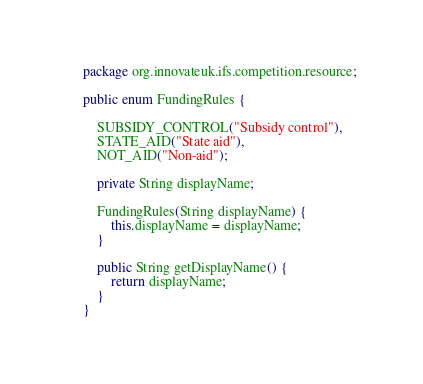Convert code to text. <code><loc_0><loc_0><loc_500><loc_500><_Java_>package org.innovateuk.ifs.competition.resource;

public enum FundingRules {

    SUBSIDY_CONTROL("Subsidy control"),
    STATE_AID("State aid"),
    NOT_AID("Non-aid");

    private String displayName;

    FundingRules(String displayName) {
        this.displayName = displayName;
    }

    public String getDisplayName() {
        return displayName;
    }
}
</code> 